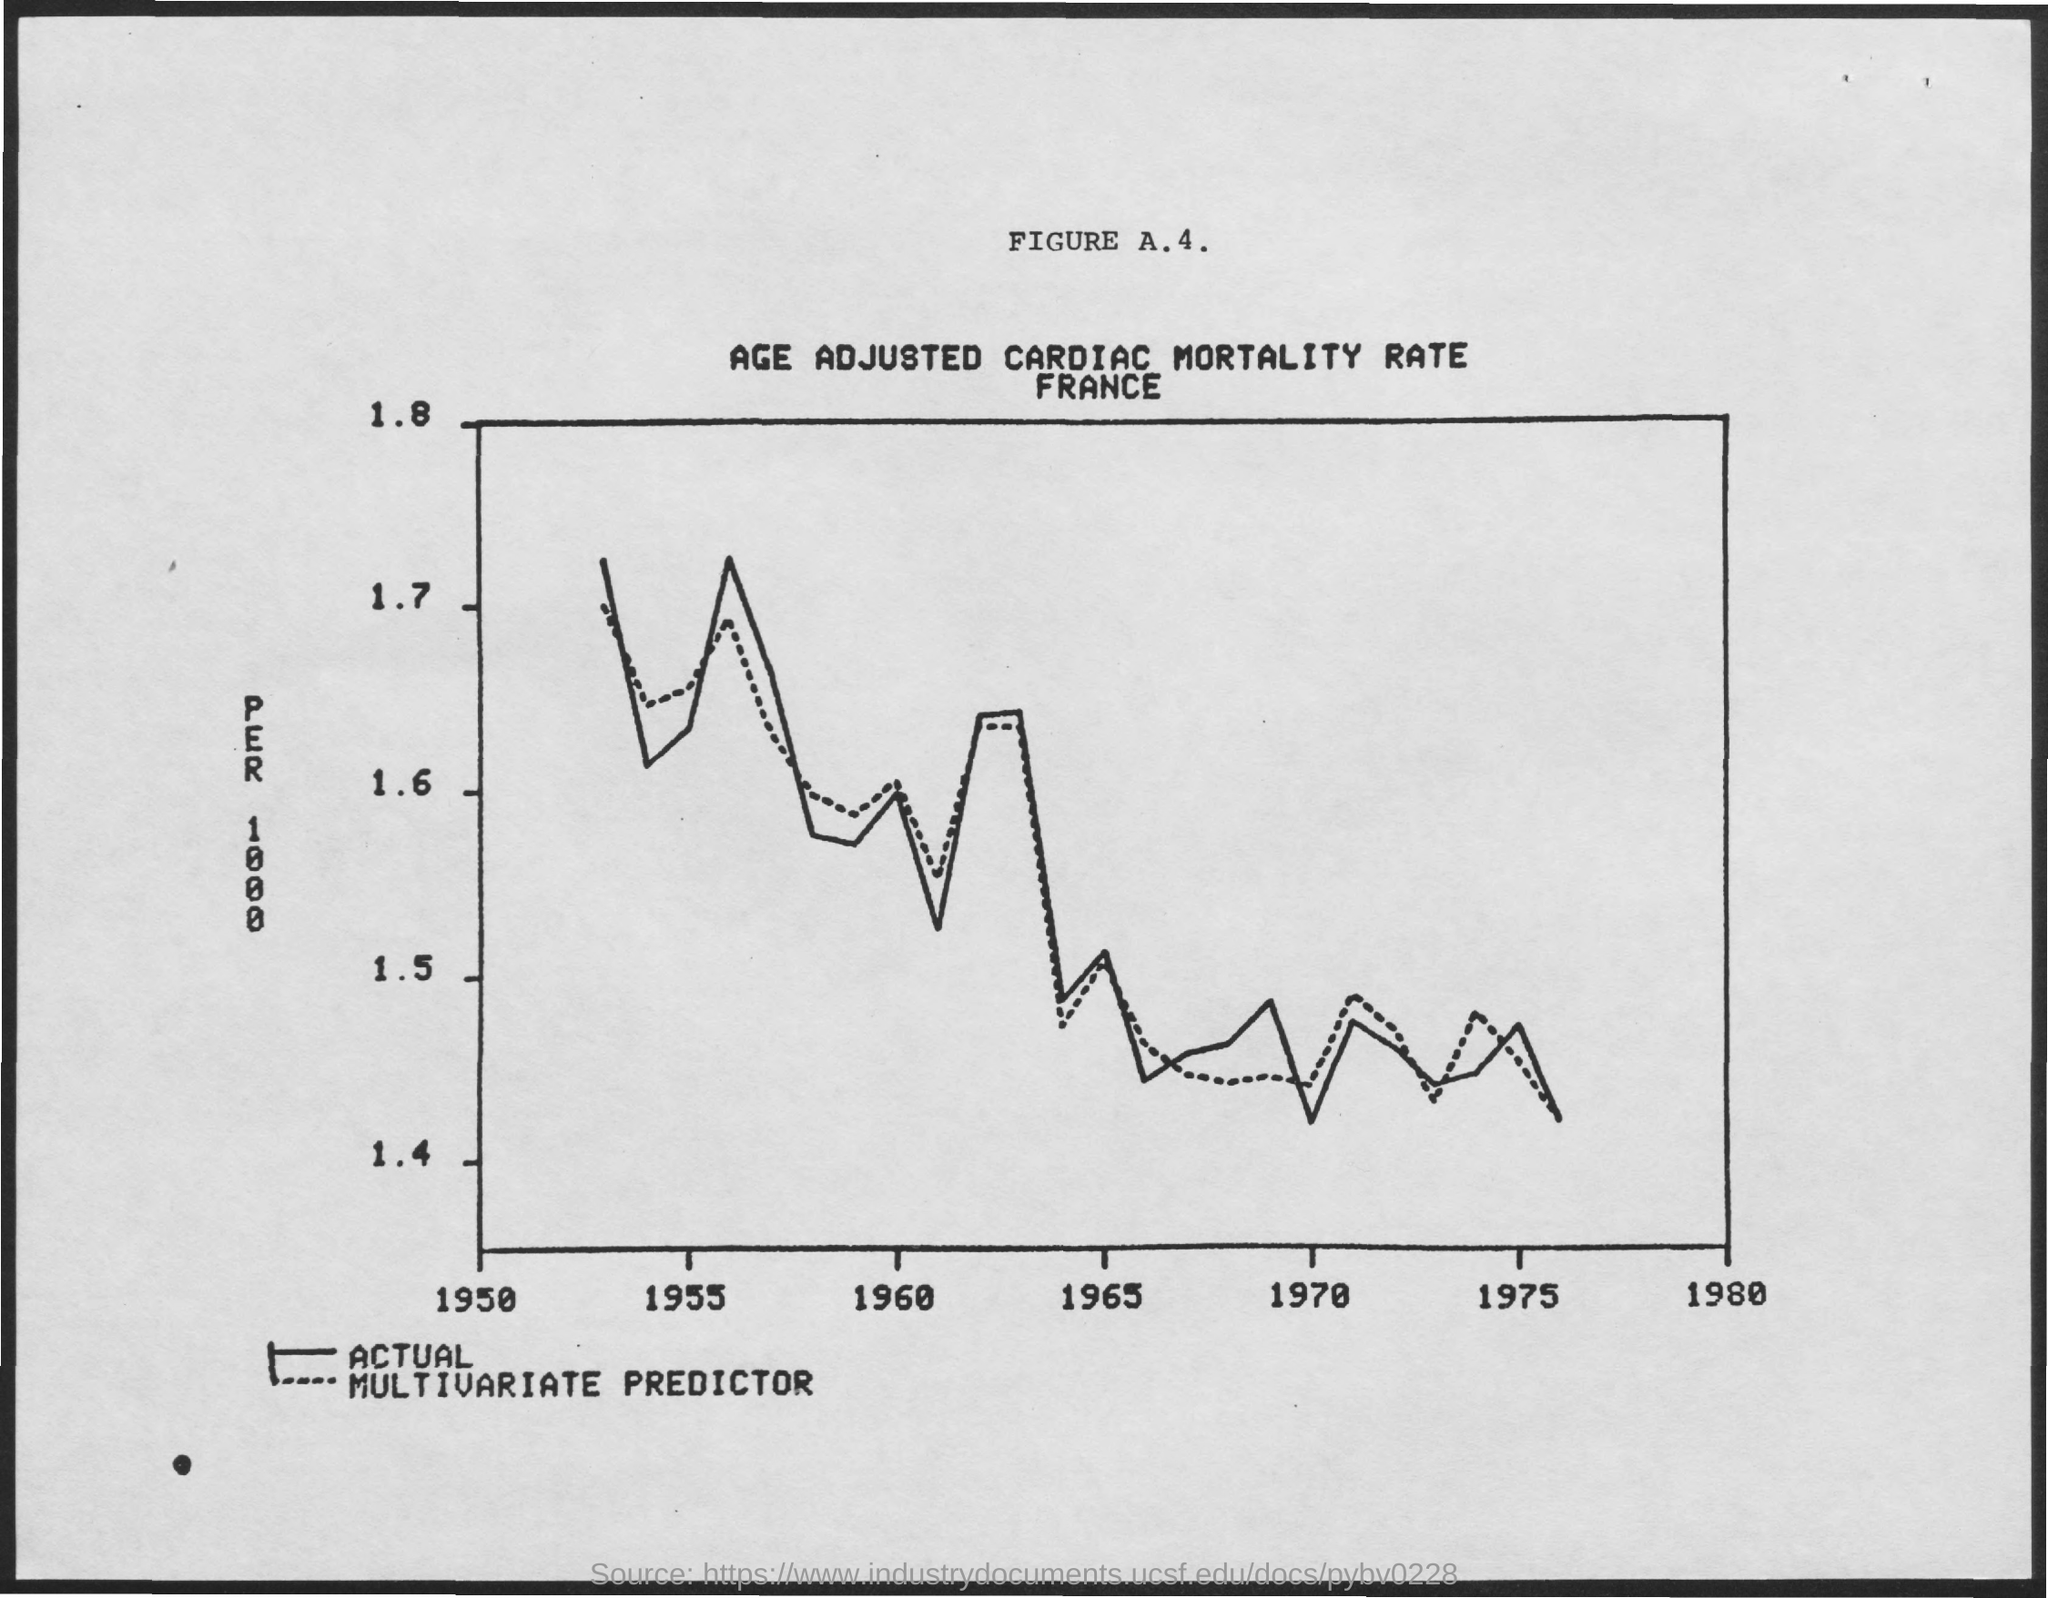What is the title of FIGURE A.4.?
Your response must be concise. AGE ADJUSTED CARDIAC MORTALITY RATE. 